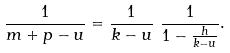<formula> <loc_0><loc_0><loc_500><loc_500>\frac { 1 } { m + p - u } & = \frac { 1 } { k - u } \ \frac { 1 } { 1 - \frac { h } { k - u } } .</formula> 